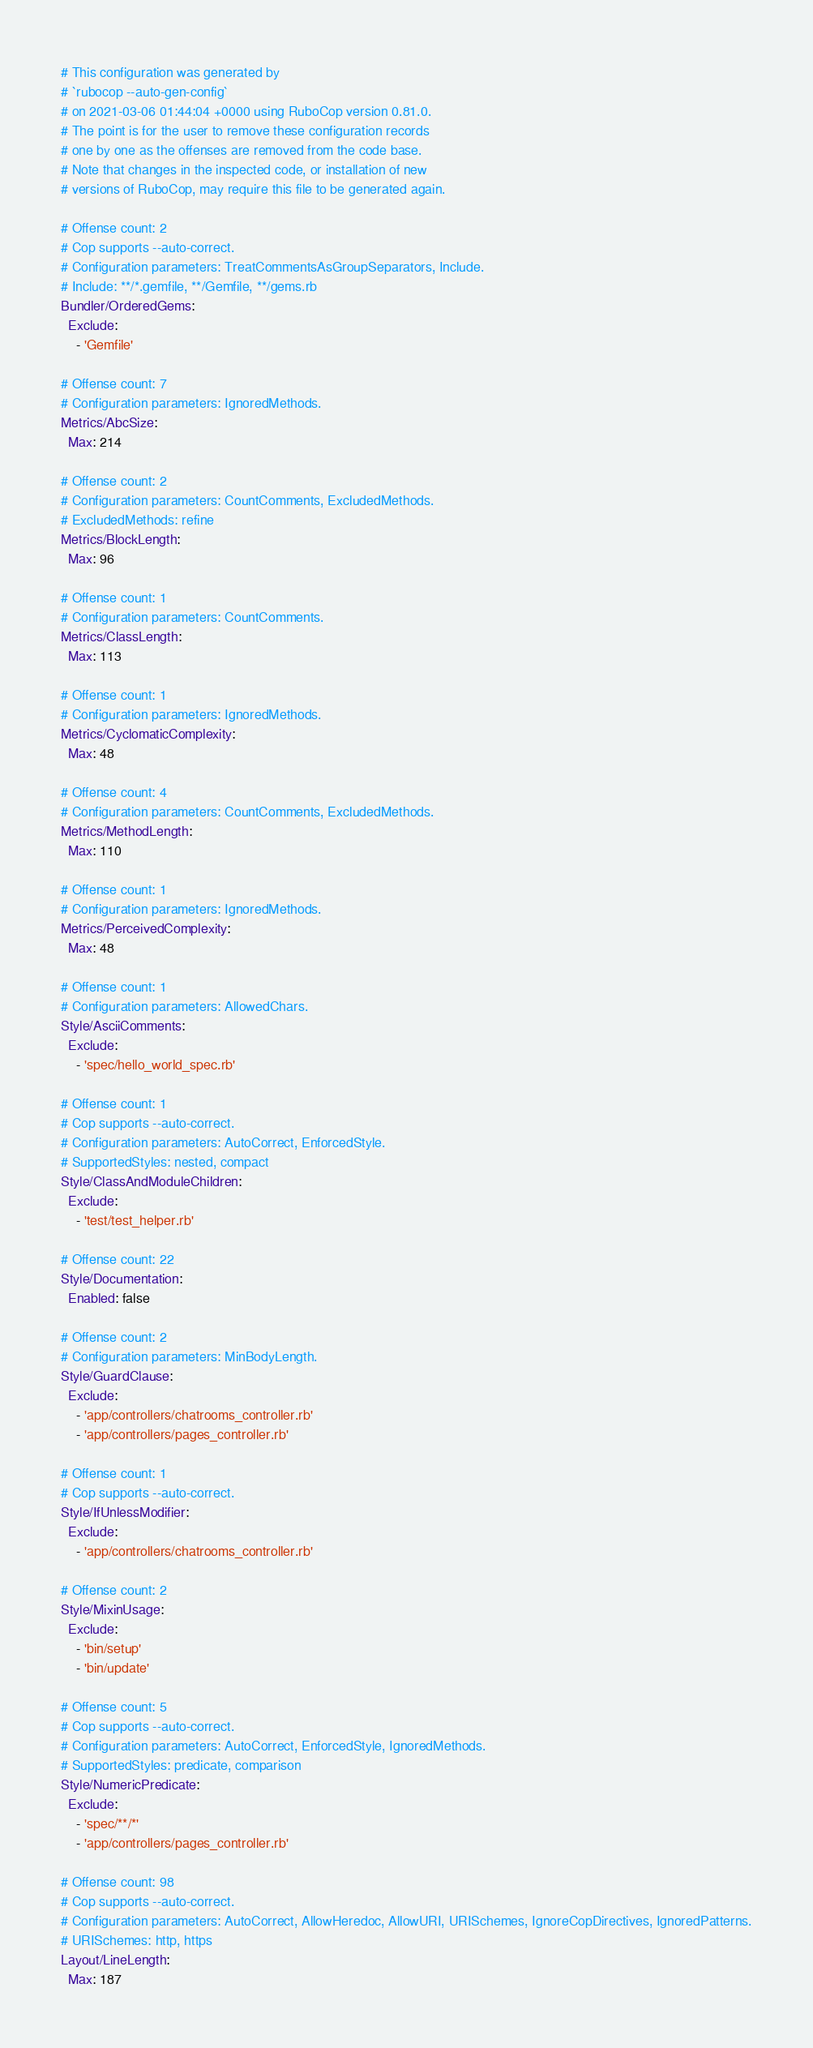<code> <loc_0><loc_0><loc_500><loc_500><_YAML_># This configuration was generated by
# `rubocop --auto-gen-config`
# on 2021-03-06 01:44:04 +0000 using RuboCop version 0.81.0.
# The point is for the user to remove these configuration records
# one by one as the offenses are removed from the code base.
# Note that changes in the inspected code, or installation of new
# versions of RuboCop, may require this file to be generated again.

# Offense count: 2
# Cop supports --auto-correct.
# Configuration parameters: TreatCommentsAsGroupSeparators, Include.
# Include: **/*.gemfile, **/Gemfile, **/gems.rb
Bundler/OrderedGems:
  Exclude:
    - 'Gemfile'

# Offense count: 7
# Configuration parameters: IgnoredMethods.
Metrics/AbcSize:
  Max: 214

# Offense count: 2
# Configuration parameters: CountComments, ExcludedMethods.
# ExcludedMethods: refine
Metrics/BlockLength:
  Max: 96

# Offense count: 1
# Configuration parameters: CountComments.
Metrics/ClassLength:
  Max: 113

# Offense count: 1
# Configuration parameters: IgnoredMethods.
Metrics/CyclomaticComplexity:
  Max: 48

# Offense count: 4
# Configuration parameters: CountComments, ExcludedMethods.
Metrics/MethodLength:
  Max: 110

# Offense count: 1
# Configuration parameters: IgnoredMethods.
Metrics/PerceivedComplexity:
  Max: 48

# Offense count: 1
# Configuration parameters: AllowedChars.
Style/AsciiComments:
  Exclude:
    - 'spec/hello_world_spec.rb'

# Offense count: 1
# Cop supports --auto-correct.
# Configuration parameters: AutoCorrect, EnforcedStyle.
# SupportedStyles: nested, compact
Style/ClassAndModuleChildren:
  Exclude:
    - 'test/test_helper.rb'

# Offense count: 22
Style/Documentation:
  Enabled: false

# Offense count: 2
# Configuration parameters: MinBodyLength.
Style/GuardClause:
  Exclude:
    - 'app/controllers/chatrooms_controller.rb'
    - 'app/controllers/pages_controller.rb'

# Offense count: 1
# Cop supports --auto-correct.
Style/IfUnlessModifier:
  Exclude:
    - 'app/controllers/chatrooms_controller.rb'

# Offense count: 2
Style/MixinUsage:
  Exclude:
    - 'bin/setup'
    - 'bin/update'

# Offense count: 5
# Cop supports --auto-correct.
# Configuration parameters: AutoCorrect, EnforcedStyle, IgnoredMethods.
# SupportedStyles: predicate, comparison
Style/NumericPredicate:
  Exclude:
    - 'spec/**/*'
    - 'app/controllers/pages_controller.rb'

# Offense count: 98
# Cop supports --auto-correct.
# Configuration parameters: AutoCorrect, AllowHeredoc, AllowURI, URISchemes, IgnoreCopDirectives, IgnoredPatterns.
# URISchemes: http, https
Layout/LineLength:
  Max: 187
</code> 